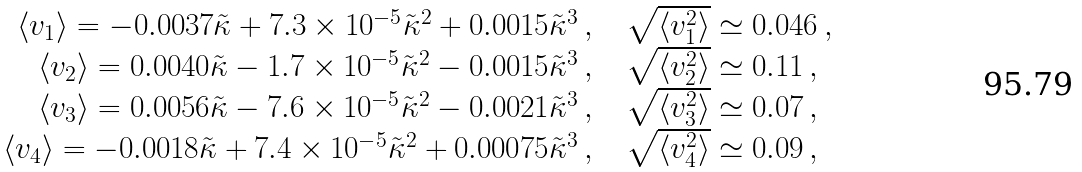Convert formula to latex. <formula><loc_0><loc_0><loc_500><loc_500>\begin{array} { r c l } \langle v _ { 1 } \rangle = - 0 . 0 0 3 7 \tilde { \kappa } + 7 . 3 \times 1 0 ^ { - 5 } \tilde { \kappa } ^ { 2 } + 0 . 0 0 1 5 \tilde { \kappa } ^ { 3 } \, , & & \sqrt { \langle v _ { 1 } ^ { 2 } \rangle } \simeq 0 . 0 4 6 \, , \\ \langle v _ { 2 } \rangle = 0 . 0 0 4 0 \tilde { \kappa } - 1 . 7 \times 1 0 ^ { - 5 } \tilde { \kappa } ^ { 2 } - 0 . 0 0 1 5 \tilde { \kappa } ^ { 3 } \, , & & \sqrt { \langle v _ { 2 } ^ { 2 } \rangle } \simeq 0 . 1 1 \, , \\ \langle v _ { 3 } \rangle = 0 . 0 0 5 6 \tilde { \kappa } - 7 . 6 \times 1 0 ^ { - 5 } \tilde { \kappa } ^ { 2 } - 0 . 0 0 2 1 \tilde { \kappa } ^ { 3 } \, , & & \sqrt { \langle v _ { 3 } ^ { 2 } \rangle } \simeq 0 . 0 7 \, , \\ \langle v _ { 4 } \rangle = - 0 . 0 0 1 8 \tilde { \kappa } + 7 . 4 \times 1 0 ^ { - 5 } \tilde { \kappa } ^ { 2 } + 0 . 0 0 0 7 5 \tilde { \kappa } ^ { 3 } \, , & & \sqrt { \langle v _ { 4 } ^ { 2 } \rangle } \simeq 0 . 0 9 \, , \end{array}</formula> 